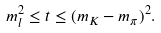Convert formula to latex. <formula><loc_0><loc_0><loc_500><loc_500>m ^ { 2 } _ { l } \leq t \leq ( m _ { K } - m _ { \pi } ) ^ { 2 } .</formula> 